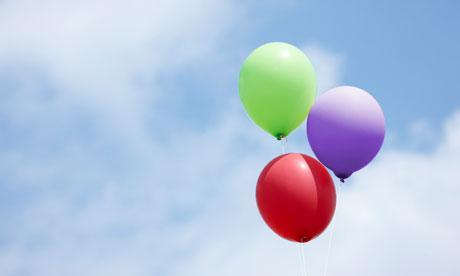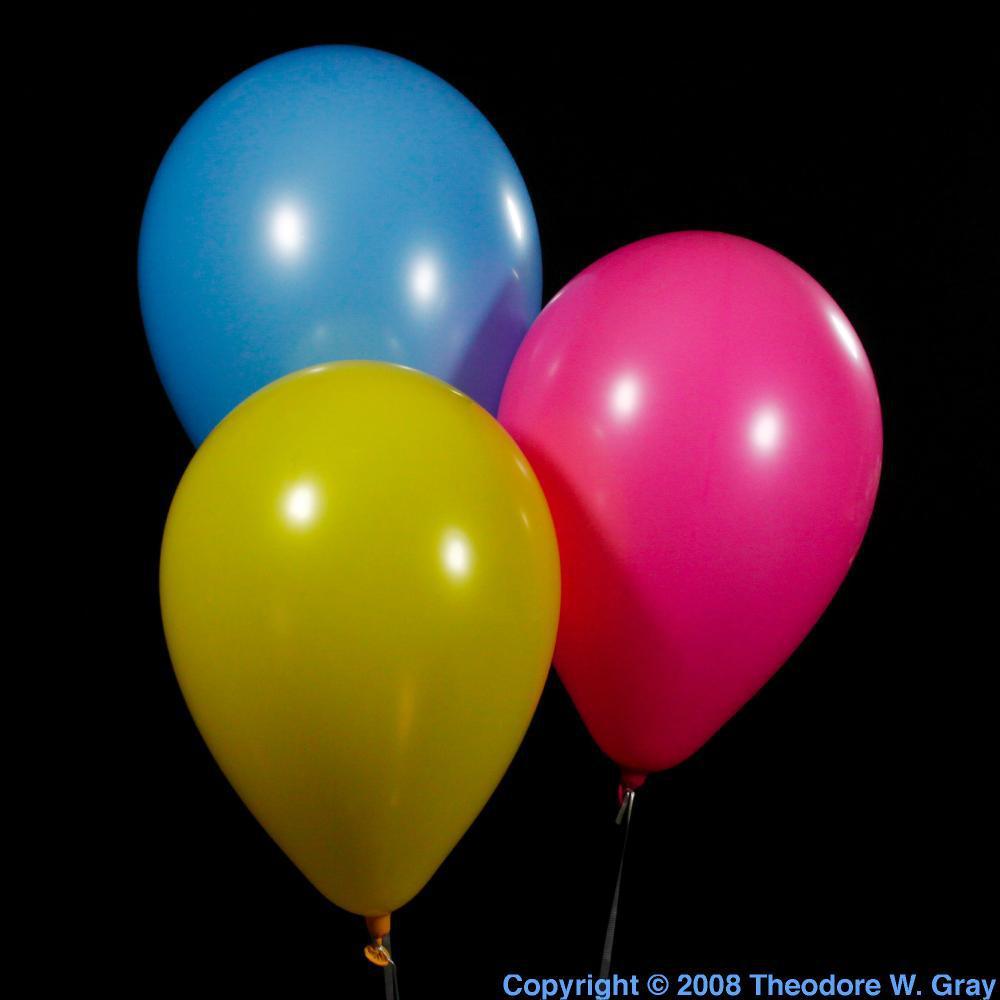The first image is the image on the left, the second image is the image on the right. Given the left and right images, does the statement "At least one of the images has a trio of balloons that represent the primary colors." hold true? Answer yes or no. No. 